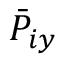Convert formula to latex. <formula><loc_0><loc_0><loc_500><loc_500>\bar { P } _ { i y }</formula> 